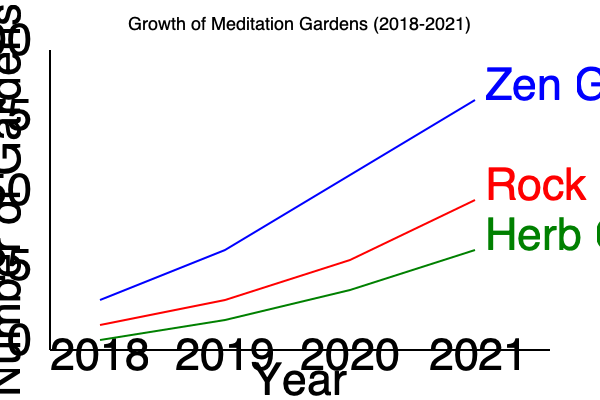Analyzing the growth patterns of different types of meditation gardens from 2018 to 2021, which garden type showed the most consistent rate of increase, and what was its approximate average annual growth? To determine the most consistent rate of increase and calculate the average annual growth:

1. Examine the slopes of each line:
   - Zen Garden: Steepest and most variable slope
   - Rock Garden: Moderate slope with some variation
   - Herb Garden: Gentlest and most consistent slope

2. The Herb Garden shows the most consistent rate of increase.

3. Calculate the Herb Garden's average annual growth:
   - 2018 starting point: ~10 gardens
   - 2021 ending point: ~50 gardens
   - Total increase: 50 - 10 = 40 gardens
   - Time period: 3 years (2018 to 2021)
   - Average annual growth: $\frac{40 \text{ gardens}}{3 \text{ years}} \approx 13.33$ gardens per year

4. Round to the nearest whole number: 13 gardens per year

Therefore, the Herb Garden showed the most consistent rate of increase with an approximate average annual growth of 13 gardens per year.
Answer: Herb Garden; 13 gardens/year 